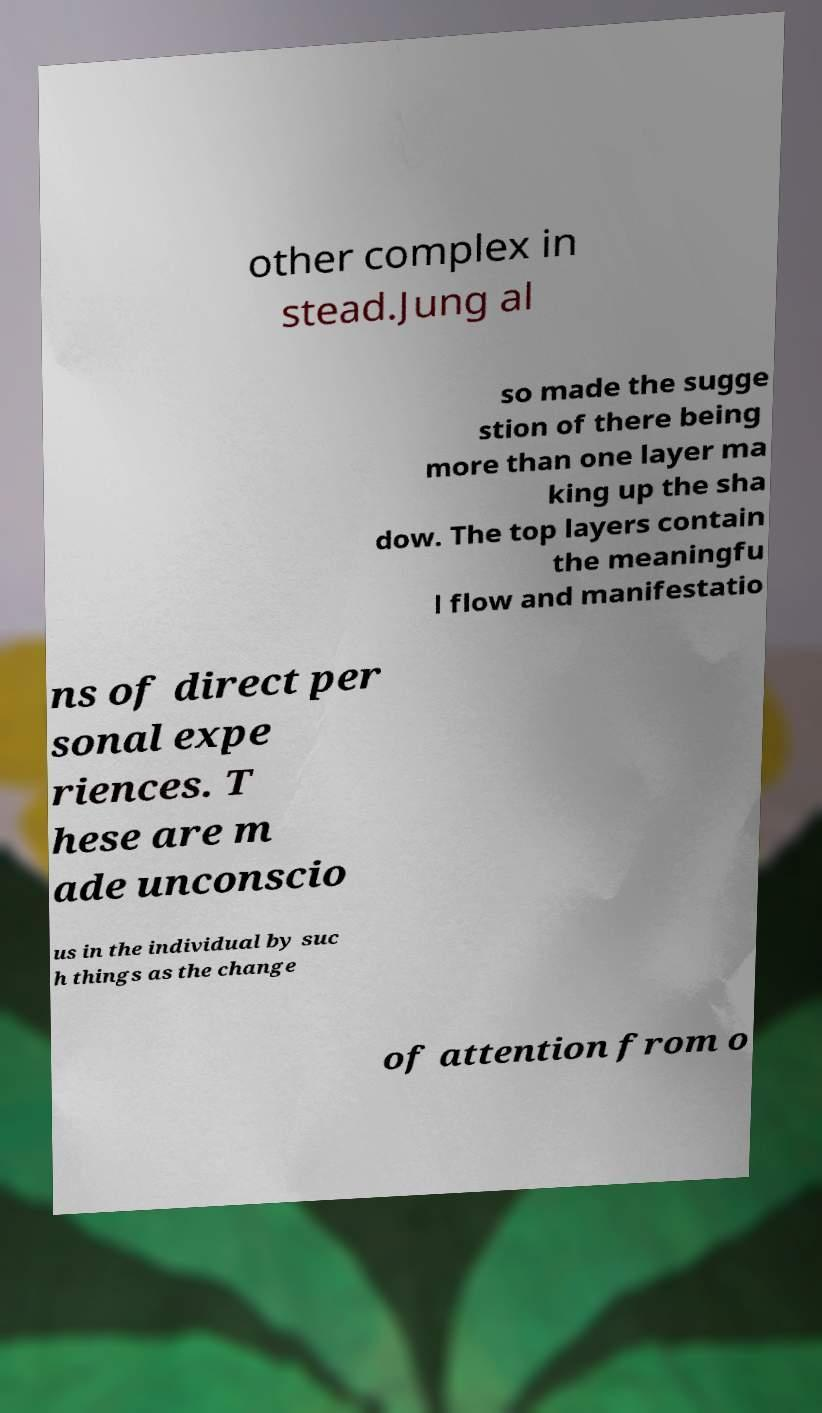Can you accurately transcribe the text from the provided image for me? other complex in stead.Jung al so made the sugge stion of there being more than one layer ma king up the sha dow. The top layers contain the meaningfu l flow and manifestatio ns of direct per sonal expe riences. T hese are m ade unconscio us in the individual by suc h things as the change of attention from o 